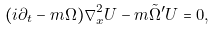<formula> <loc_0><loc_0><loc_500><loc_500>( i \partial _ { t } - m \Omega ) \nabla ^ { 2 } _ { x } U - m \tilde { \Omega } ^ { \prime } U = 0 ,</formula> 